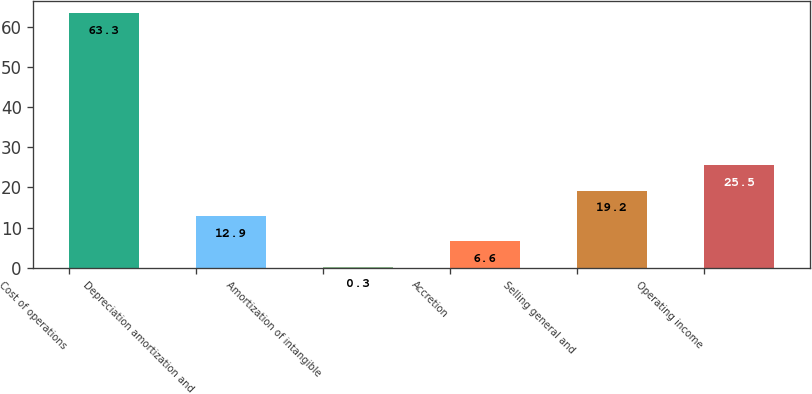Convert chart. <chart><loc_0><loc_0><loc_500><loc_500><bar_chart><fcel>Cost of operations<fcel>Depreciation amortization and<fcel>Amortization of intangible<fcel>Accretion<fcel>Selling general and<fcel>Operating income<nl><fcel>63.3<fcel>12.9<fcel>0.3<fcel>6.6<fcel>19.2<fcel>25.5<nl></chart> 